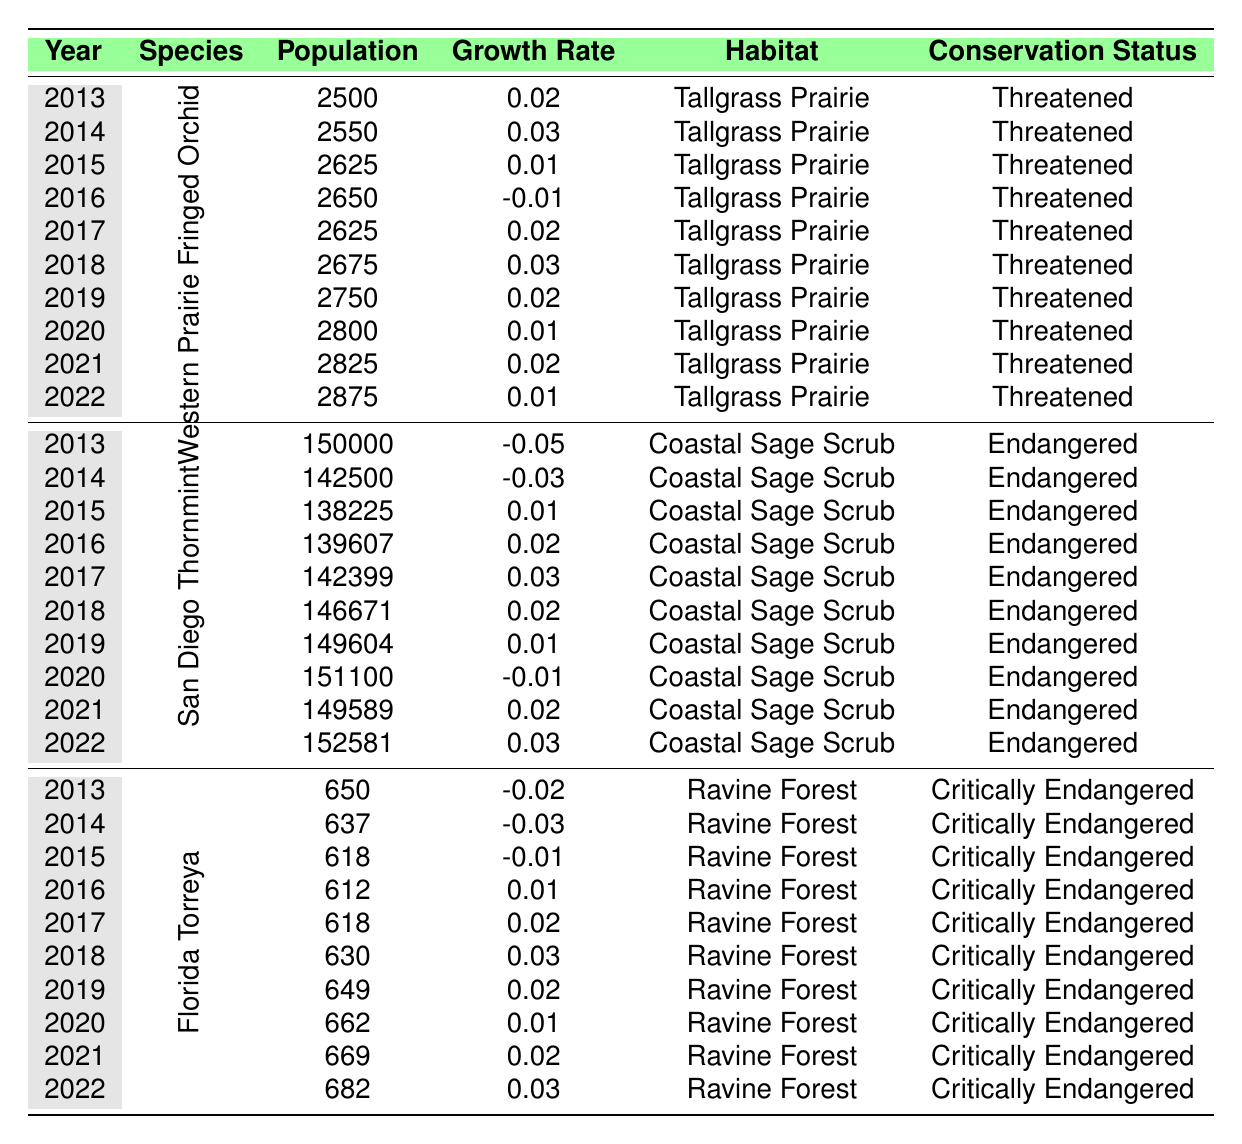What is the population of the Western Prairie Fringed Orchid in 2022? The table shows that the population of the Western Prairie Fringed Orchid in 2022 is listed directly under that species. The value is 2875.
Answer: 2875 What was the highest population recorded for the San Diego Thornmint over the decade? Looking through the data for the San Diego Thornmint, the highest population recorded appears to be 150000 in 2013.
Answer: 150000 What is the average growth rate of the Florida Torreya from 2013 to 2022? The growth rates from 2013 to 2022 for the Florida Torreya are: -0.02, -0.03, -0.01, 0.01, 0.02, 0.03, 0.02, 0.01, 0.02, 0.03. Adding these together gives a total of 0.03. Dividing by the 10 years yields an average growth rate of 0.003.
Answer: 0.003 Did the population of the Western Prairie Fringed Orchid increase or decrease from 2016 to 2017? The population in 2016 was 2650, and in 2017 it was 2625, indicating a decrease.
Answer: Decrease Which species had a negative growth rate more frequently, and what were those years? Analyzing the growth rates, the Florida Torreya had negative growth rates in 2013, 2014, and 2015, while the San Diego Thornmint had negative growth rates in 2013 and 2014. Thus, the Florida Torreya had negative growth rates more frequently.
Answer: Florida Torreya; years: 2013, 2014, 2015 What year had the lowest population for the Florida Torreya and what was that population? The table shows that the lowest population for the Florida Torreya is 612, which was recorded in 2016.
Answer: 612 in 2016 For the San Diego Thornmint, what was the difference in population from 2013 to 2022? The population in 2013 was 150000 and in 2022 it was 152581. The difference is calculated as 152581 - 150000 = 2581.
Answer: 2581 How many species were listed as critically endangered in the table? Only one species, the Florida Torreya, is listed under the conservation status of critically endangered in the table.
Answer: 1 What trend can be observed in the population of the Western Prairie Fringed Orchid over the decade? By analyzing the population values from 2013 to 2022, it can be observed that the population generally increased, despite some fluctuations, with a final population of 2875 in 2022 compared to 2500 in 2013.
Answer: Generally increasing trend Which species had the highest growth rate in any given year? The highest annual growth rate observed was 0.03, which was noted for both the Western Prairie Fringed Orchid in 2018 and the Florida Torreya in 2018.
Answer: 0.03 What was the conservation status of the San Diego Thornmint through the years? The conservation status of the San Diego Thornmint remained consistent as endangered throughout the years shown in the table.
Answer: Endangered 